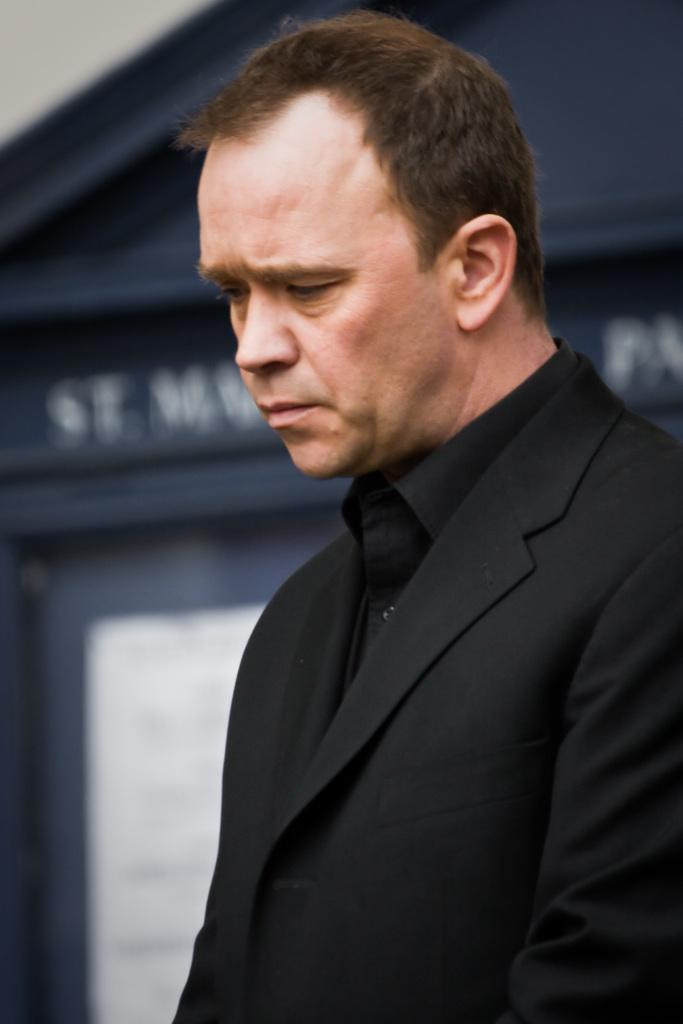What is the man in the image wearing? The man is wearing a black suit. What can be seen behind the man in the image? There is a door visible in the image. Is there any text present in the image? Yes, there is some text present in the image. What type of oatmeal is the man eating in the image? There is no oatmeal present in the image; the man is wearing a black suit and standing near a door. How many goldfish are visible in the image? There are no goldfish present in the image. 